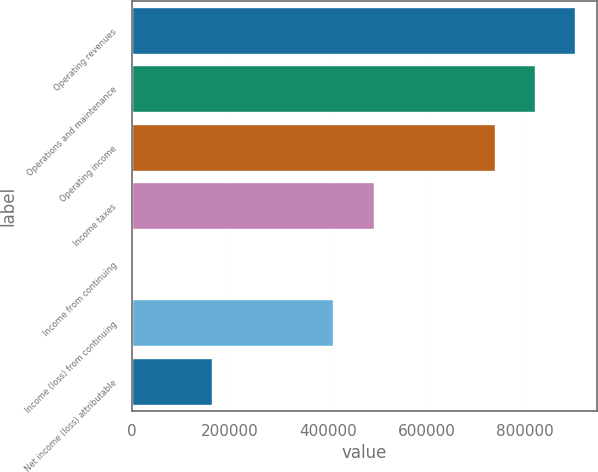Convert chart to OTSL. <chart><loc_0><loc_0><loc_500><loc_500><bar_chart><fcel>Operating revenues<fcel>Operations and maintenance<fcel>Operating income<fcel>Income taxes<fcel>Income from continuing<fcel>Income (loss) from continuing<fcel>Net income (loss) attributable<nl><fcel>902653<fcel>820594<fcel>738535<fcel>492357<fcel>0.83<fcel>410297<fcel>164119<nl></chart> 